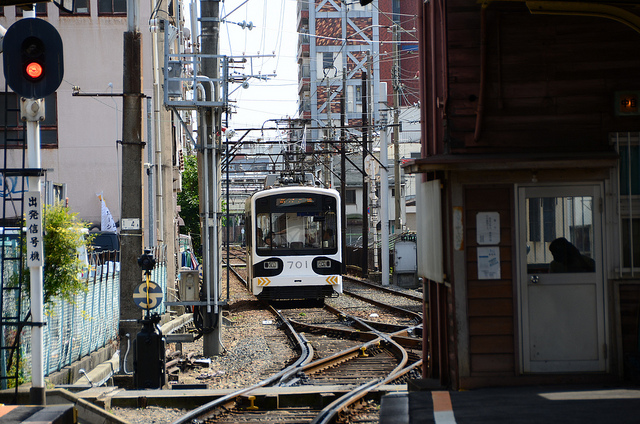Please transcribe the text in this image. 701 S 